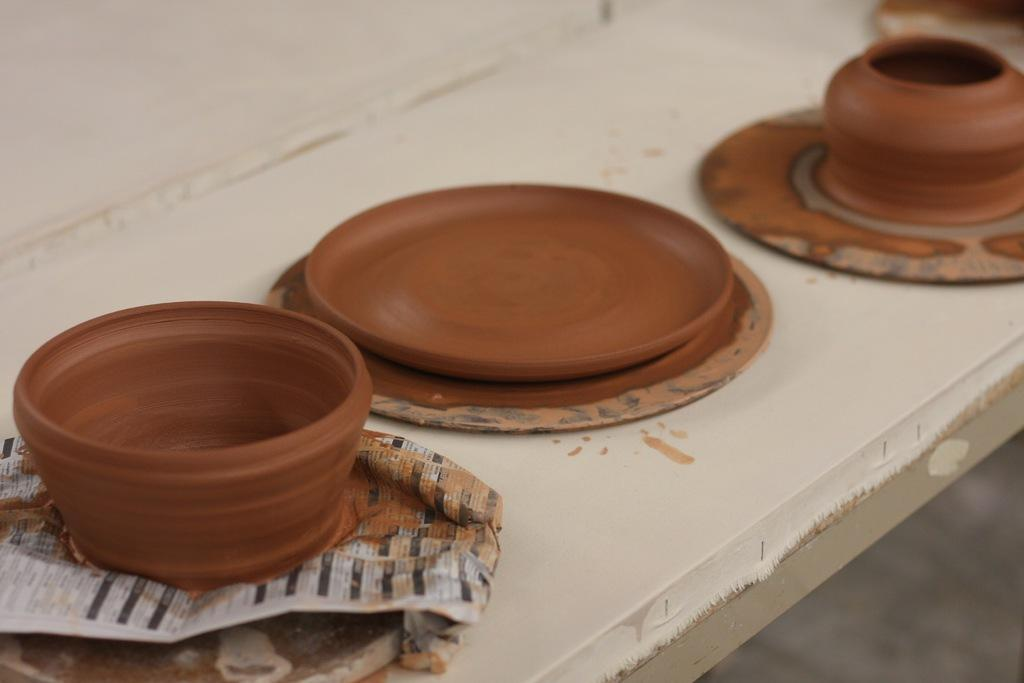What type of objects can be seen in the image? There is earthenware and a paper in the image. Where are these objects located? Both objects are on a platform. Can you describe the earthenware in the image? The earthenware is a type of pottery, typically made from clay and fired in a kiln. What is the purpose of the paper in the image? The purpose of the paper is not specified in the image, but it could be used for writing, drawing, or wrapping. How many beds are visible in the image? There are no beds present in the image. What type of brass material can be seen in the image? There is no brass material present in the image. 